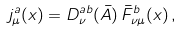<formula> <loc_0><loc_0><loc_500><loc_500>j ^ { a } _ { \mu } ( x ) = D ^ { a b } _ { \nu } ( \bar { A } ) \, \bar { F } ^ { b } _ { \nu \mu } ( x ) \, ,</formula> 